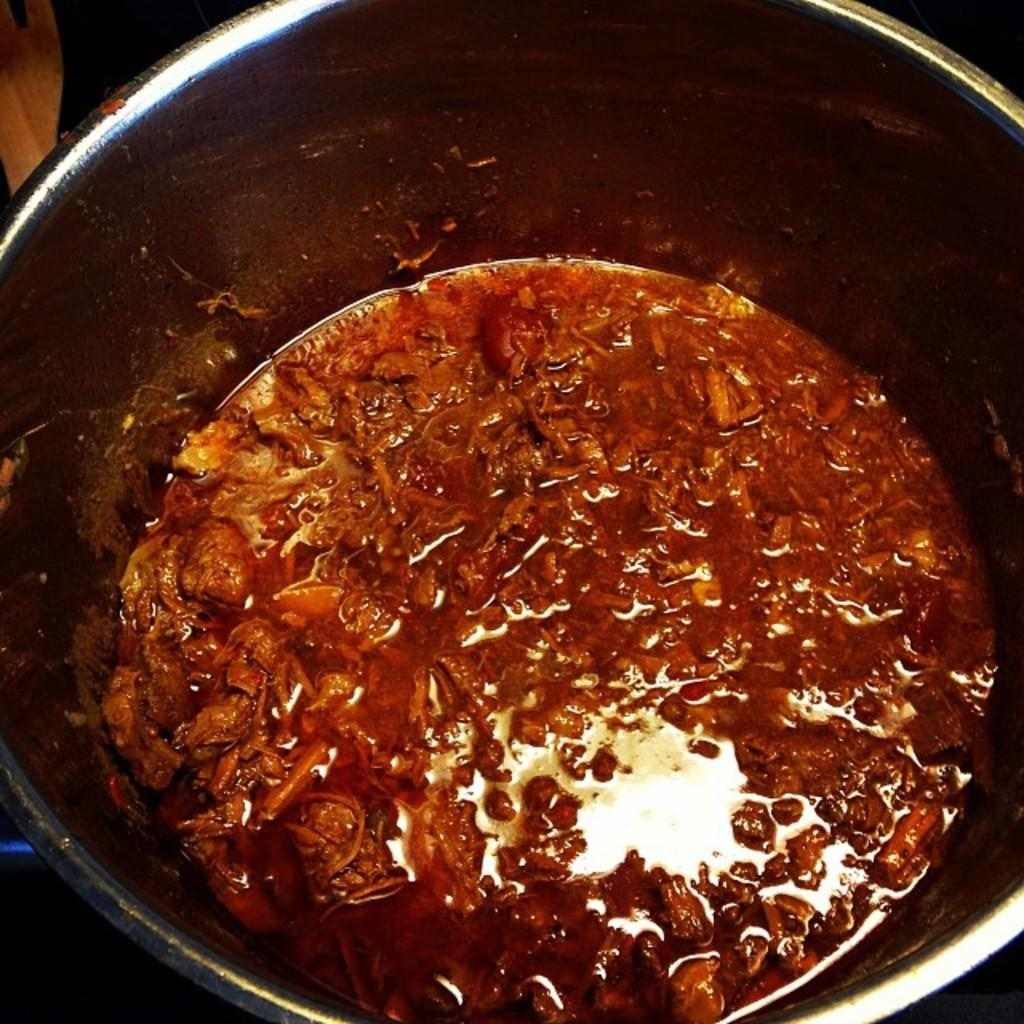What is in the vessel that is visible in the image? There is food in a vessel in the image. Can you describe the type of food in the vessel? The food appears to be a curry. What color is the curry in the image? The curry has a red color. How many fish can be seen swimming in the curry in the image? There are no fish visible in the curry in the image. Is there any evidence of a seed exchange happening in the image? There is no indication of a seed exchange happening in the image. 